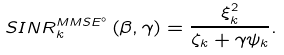Convert formula to latex. <formula><loc_0><loc_0><loc_500><loc_500>S I N R ^ { M M S E ^ { \circ } } _ { k } \left ( \beta , \gamma \right ) = \frac { \xi _ { k } ^ { 2 } } { \zeta _ { k } + \gamma \psi _ { k } } .</formula> 